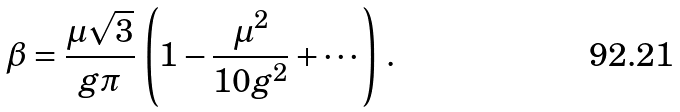<formula> <loc_0><loc_0><loc_500><loc_500>\beta = \frac { \mu \sqrt { 3 } } { g \pi } \, \left ( 1 - \frac { \mu ^ { 2 } } { 1 0 g ^ { 2 } } + \cdots \right ) \, .</formula> 